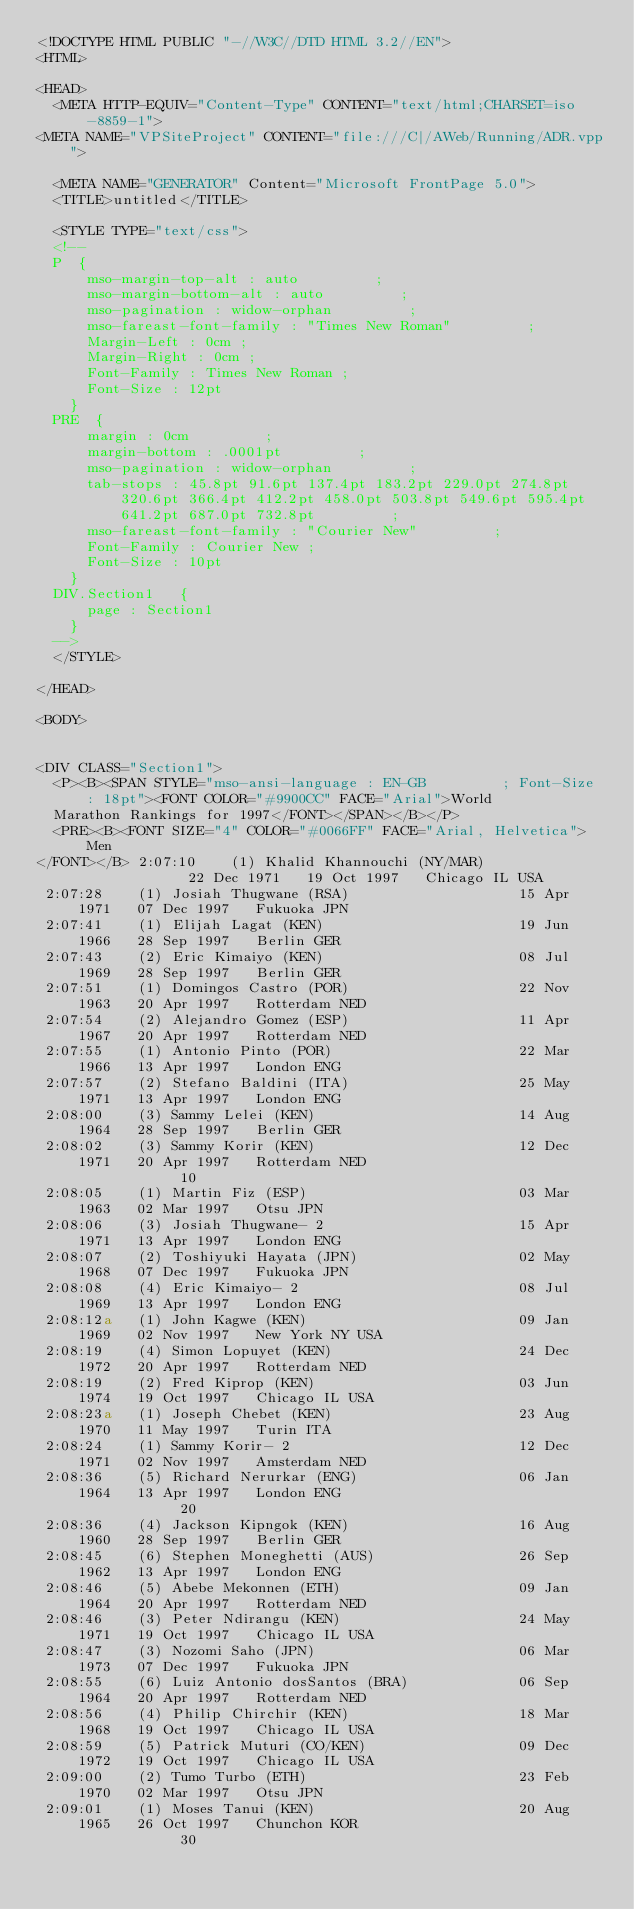Convert code to text. <code><loc_0><loc_0><loc_500><loc_500><_HTML_><!DOCTYPE HTML PUBLIC "-//W3C//DTD HTML 3.2//EN">
<HTML>

<HEAD>
	<META HTTP-EQUIV="Content-Type" CONTENT="text/html;CHARSET=iso-8859-1">
<META NAME="VPSiteProject" CONTENT="file:///C|/AWeb/Running/ADR.vpp">

	<META NAME="GENERATOR" Content="Microsoft FrontPage 5.0">
	<TITLE>untitled</TITLE>

	<STYLE TYPE="text/css">
	<!--
	P	 {
			mso-margin-top-alt : auto         ;
			mso-margin-bottom-alt : auto         ;
			mso-pagination : widow-orphan         ;
			mso-fareast-font-family : "Times New Roman"         ;
			Margin-Left : 0cm ;
			Margin-Right : 0cm ;
			Font-Family : Times New Roman ;
			Font-Size : 12pt
		}
	PRE	 {
			margin : 0cm         ;
			margin-bottom : .0001pt         ;
			mso-pagination : widow-orphan         ;
			tab-stops : 45.8pt 91.6pt 137.4pt 183.2pt 229.0pt 274.8pt 320.6pt 366.4pt 412.2pt 458.0pt 503.8pt 549.6pt 595.4pt 641.2pt 687.0pt 732.8pt         ;
			mso-fareast-font-family : "Courier New"         ;
			Font-Family : Courier New ;
			Font-Size : 10pt
		}
	DIV.Section1	 {
			page : Section1
		}
	-->
	</STYLE>

</HEAD>

<BODY>


<DIV CLASS="Section1">
	<P><B><SPAN STYLE="mso-ansi-language : EN-GB         ; Font-Size : 18pt"><FONT COLOR="#9900CC" FACE="Arial">World
	Marathon Rankings for 1997</FONT></SPAN></B></P>
	<PRE><B><FONT SIZE="4" COLOR="#0066FF" FACE="Arial, Helvetica">Men
</FONT></B> 2:07:10    (1) Khalid Khannouchi (NY/MAR)               22 Dec 1971   19 Oct 1997   Chicago IL USA                          
 2:07:28    (1) Josiah Thugwane (RSA)                    15 Apr 1971   07 Dec 1997   Fukuoka JPN                             
 2:07:41    (1) Elijah Lagat (KEN)                       19 Jun 1966   28 Sep 1997   Berlin GER                              
 2:07:43    (2) Eric Kimaiyo (KEN)                       08 Jul 1969   28 Sep 1997   Berlin GER                              
 2:07:51    (1) Domingos Castro (POR)                    22 Nov 1963   20 Apr 1997   Rotterdam NED                           
 2:07:54    (2) Alejandro Gomez (ESP)                    11 Apr 1967   20 Apr 1997   Rotterdam NED                           
 2:07:55    (1) Antonio Pinto (POR)                      22 Mar 1966   13 Apr 1997   London ENG                              
 2:07:57    (2) Stefano Baldini (ITA)                    25 May 1971   13 Apr 1997   London ENG                              
 2:08:00    (3) Sammy Lelei (KEN)                        14 Aug 1964   28 Sep 1997   Berlin GER                              
 2:08:02    (3) Sammy Korir (KEN)                        12 Dec 1971   20 Apr 1997   Rotterdam NED                           
                 10
 2:08:05    (1) Martin Fiz (ESP)                         03 Mar 1963   02 Mar 1997   Otsu JPN                                
 2:08:06    (3) Josiah Thugwane- 2                       15 Apr 1971   13 Apr 1997   London ENG                              
 2:08:07    (2) Toshiyuki Hayata (JPN)                   02 May 1968   07 Dec 1997   Fukuoka JPN                             
 2:08:08    (4) Eric Kimaiyo- 2                          08 Jul 1969   13 Apr 1997   London ENG                              
 2:08:12a   (1) John Kagwe (KEN)                         09 Jan 1969   02 Nov 1997   New York NY USA                         
 2:08:19    (4) Simon Lopuyet (KEN)                      24 Dec 1972   20 Apr 1997   Rotterdam NED                           
 2:08:19    (2) Fred Kiprop (KEN)                        03 Jun 1974   19 Oct 1997   Chicago IL USA                          
 2:08:23a   (1) Joseph Chebet (KEN)                      23 Aug 1970   11 May 1997   Turin ITA                               
 2:08:24    (1) Sammy Korir- 2                           12 Dec 1971   02 Nov 1997   Amsterdam NED                           
 2:08:36    (5) Richard Nerurkar (ENG)                   06 Jan 1964   13 Apr 1997   London ENG                              
                 20
 2:08:36    (4) Jackson Kipngok (KEN)                    16 Aug 1960   28 Sep 1997   Berlin GER                              
 2:08:45    (6) Stephen Moneghetti (AUS)                 26 Sep 1962   13 Apr 1997   London ENG                              
 2:08:46    (5) Abebe Mekonnen (ETH)                     09 Jan 1964   20 Apr 1997   Rotterdam NED                           
 2:08:46    (3) Peter Ndirangu (KEN)                     24 May 1971   19 Oct 1997   Chicago IL USA                          
 2:08:47    (3) Nozomi Saho (JPN)                        06 Mar 1973   07 Dec 1997   Fukuoka JPN                             
 2:08:55    (6) Luiz Antonio dosSantos (BRA)             06 Sep 1964   20 Apr 1997   Rotterdam NED                           
 2:08:56    (4) Philip Chirchir (KEN)                    18 Mar 1968   19 Oct 1997   Chicago IL USA                          
 2:08:59    (5) Patrick Muturi (CO/KEN)                  09 Dec 1972   19 Oct 1997   Chicago IL USA                          
 2:09:00    (2) Tumo Turbo (ETH)                         23 Feb 1970   02 Mar 1997   Otsu JPN                                
 2:09:01    (1) Moses Tanui (KEN)                        20 Aug 1965   26 Oct 1997   Chunchon KOR                            
                 30</code> 